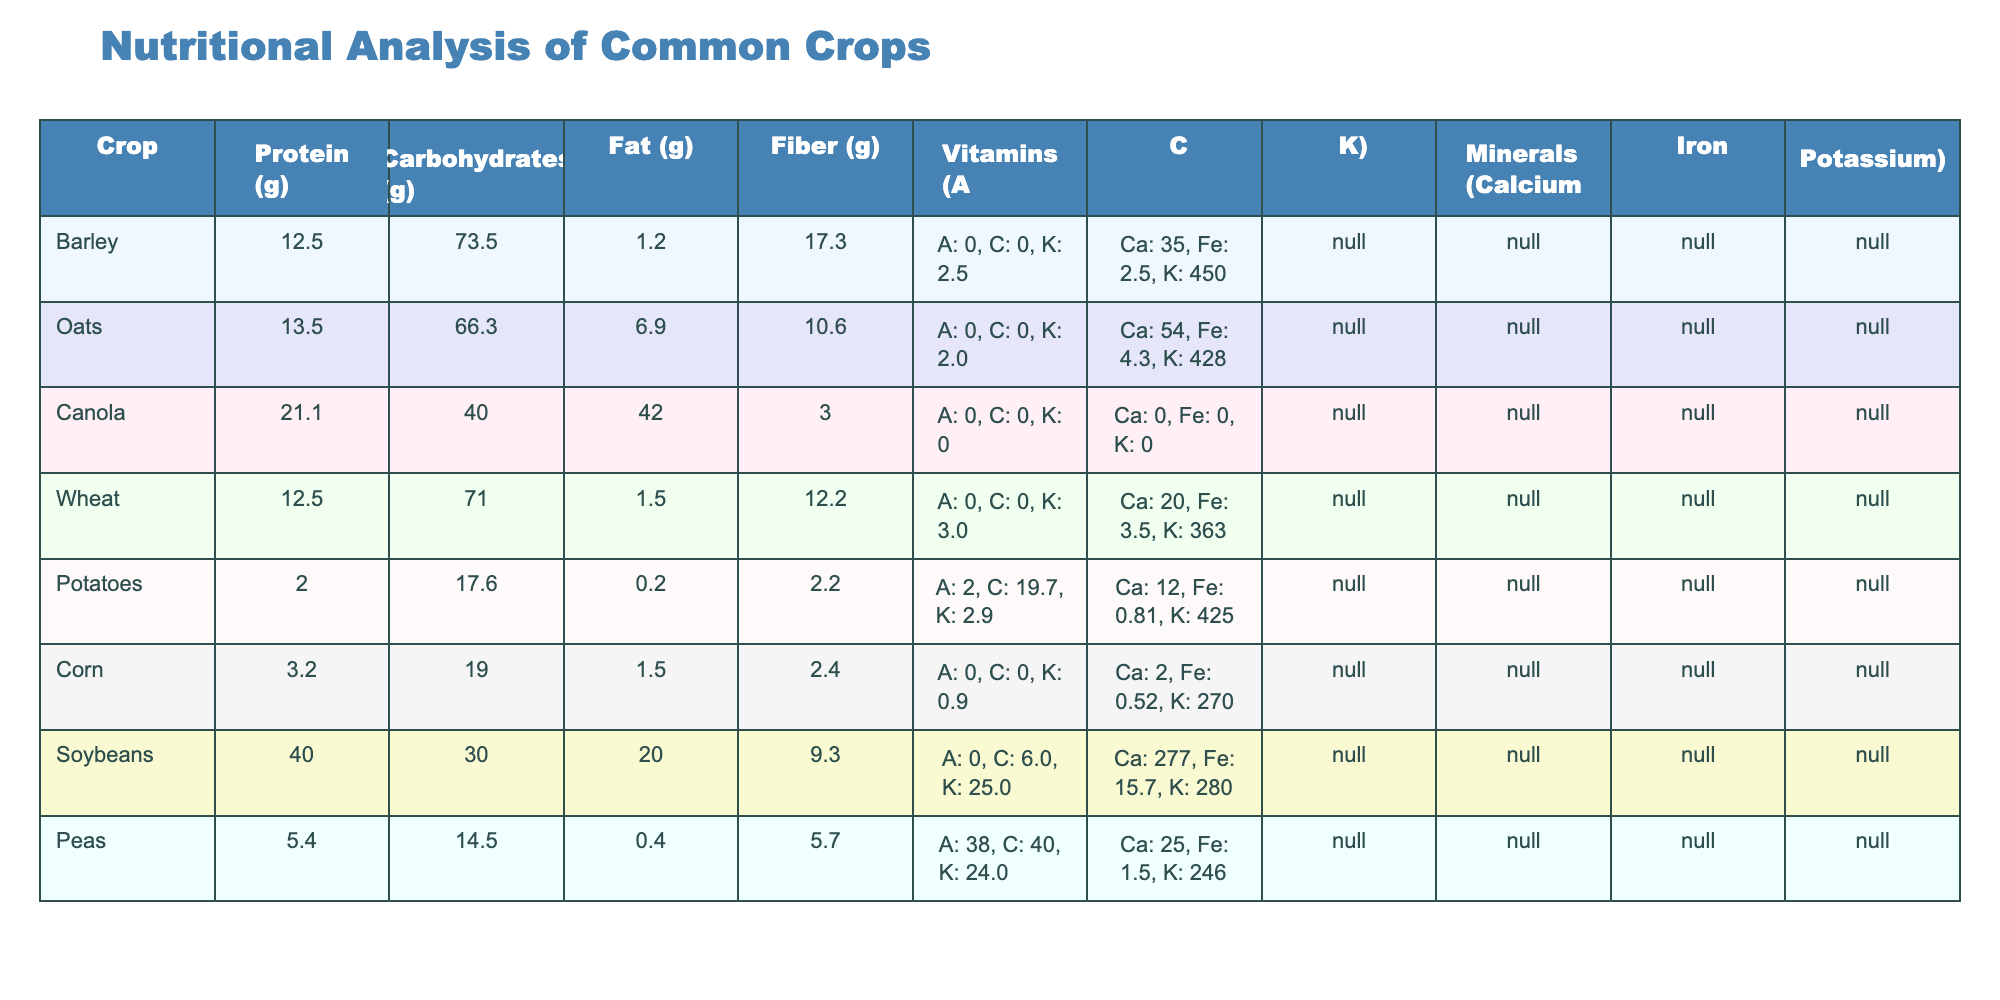What is the protein content in Soybeans? Soybeans are listed in the table, and the protein content specified in the table next to Soybeans is 40.0 g.
Answer: 40.0 g Which crop has the highest carbohydrate content? By looking at the carbohydrate values for each crop in the table, Canola has 40.0 g, which is lower than Barley (73.5 g), making Barley the crop with the highest carbohydrate content.
Answer: Barley What is the average fat content of Potatoes, Corn, and Peas? The fat content for Potatoes is 0.2 g, for Corn it is 1.5 g, and for Peas it is 0.4 g. Adding these values: 0.2 + 1.5 + 0.4 = 2.1 g. There are three crops, so the average is 2.1 g / 3 = 0.7 g.
Answer: 0.7 g Does Oats contain more fiber than Canola? Oats have a fiber content of 10.6 g while Canola has a fiber content of 3.0 g. Comparing the two, 10.6 g is greater than 3.0 g, so the answer is yes.
Answer: Yes Which crop has the highest combined mineral content of Calcium, Iron, and Potassium? To find the crop with the highest mineral contributions, we need to convert the values from string format. Barley has Ca: 35, Fe: 2.5, K: 450 summing to 487. Oats has Ca: 54, Fe: 4.3, K: 428 totaling 486. Canola has Ca: 0, Fe: 0, K: 0 making it 0. Wheat has 20 + 3.5 + 363 which sums to 386. Potatoes sum to 2 + 0.81 + 425 making it 427. Corn totals 2 + 0.52 + 270 summing to 272. Soybeans total to 277 + 15.7 + 280 equaling 572. Peas total 25 + 1.5 + 246 which sums to 272. Thus, Soybeans has the highest mineral content with a total of 572.
Answer: Soybeans Is Peas richer in vitamins than Potatoes? Peas contain A: 38, C: 40, K: 24. Potatoes have A: 2, C: 19.7, K: 2.9. By comparing the totals, Peas have a higher total from vitamins than Potatoes.
Answer: Yes 